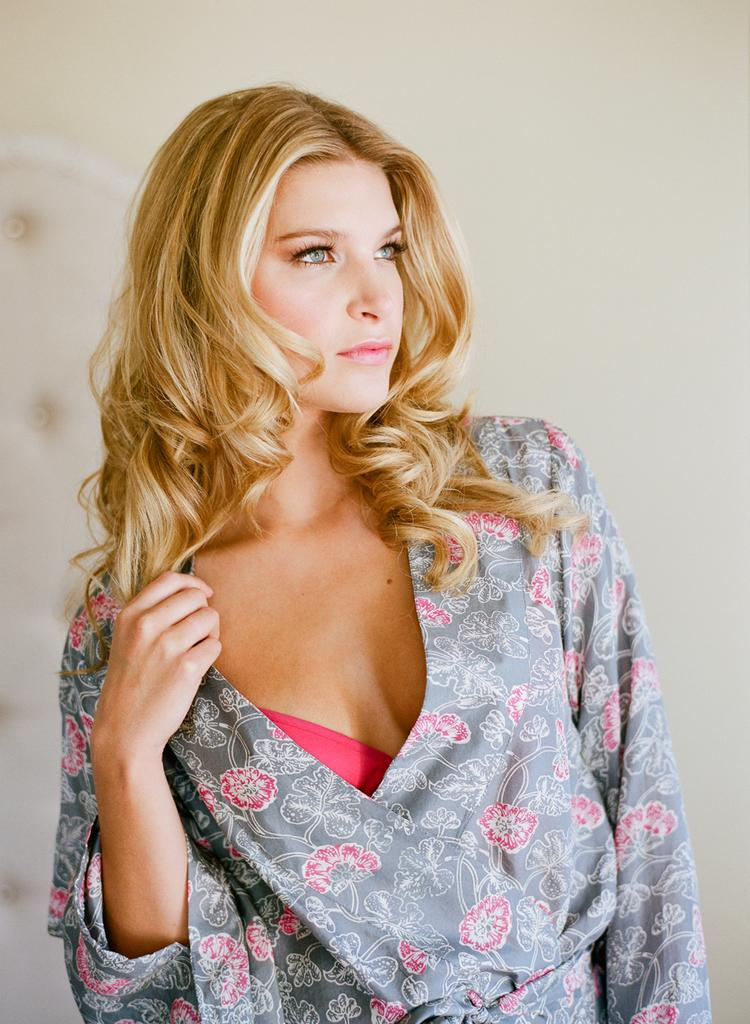Who is the main subject in the image? There is a woman in the image. What is the woman wearing? The woman is wearing a grey and pink dress. What is the color of the woman's hair? The woman has brown hair. What can be seen in the background of the image? There is a wall in the background of the image. How many babies are present in the image? There are no babies present in the image; it features a woman. What type of mint is growing on the woman's head in the image? There is no mint present in the image; the woman has brown hair. 